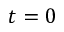<formula> <loc_0><loc_0><loc_500><loc_500>t = 0</formula> 